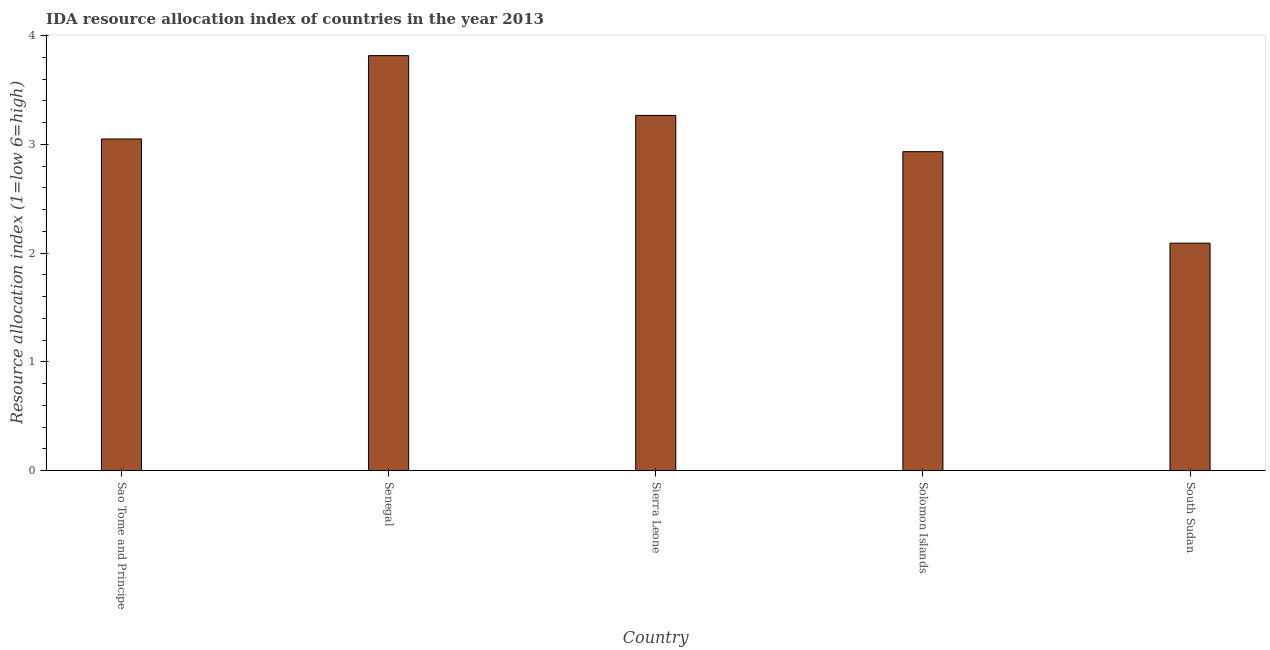Does the graph contain grids?
Keep it short and to the point. No. What is the title of the graph?
Your answer should be very brief. IDA resource allocation index of countries in the year 2013. What is the label or title of the Y-axis?
Keep it short and to the point. Resource allocation index (1=low 6=high). What is the ida resource allocation index in Senegal?
Offer a very short reply. 3.82. Across all countries, what is the maximum ida resource allocation index?
Your response must be concise. 3.82. Across all countries, what is the minimum ida resource allocation index?
Your response must be concise. 2.09. In which country was the ida resource allocation index maximum?
Provide a succinct answer. Senegal. In which country was the ida resource allocation index minimum?
Ensure brevity in your answer.  South Sudan. What is the sum of the ida resource allocation index?
Provide a succinct answer. 15.16. What is the difference between the ida resource allocation index in Sao Tome and Principe and South Sudan?
Make the answer very short. 0.96. What is the average ida resource allocation index per country?
Ensure brevity in your answer.  3.03. What is the median ida resource allocation index?
Your response must be concise. 3.05. What is the ratio of the ida resource allocation index in Sao Tome and Principe to that in Senegal?
Give a very brief answer. 0.8. Is the difference between the ida resource allocation index in Sao Tome and Principe and South Sudan greater than the difference between any two countries?
Provide a short and direct response. No. What is the difference between the highest and the second highest ida resource allocation index?
Your response must be concise. 0.55. Is the sum of the ida resource allocation index in Solomon Islands and South Sudan greater than the maximum ida resource allocation index across all countries?
Your answer should be very brief. Yes. What is the difference between the highest and the lowest ida resource allocation index?
Give a very brief answer. 1.73. In how many countries, is the ida resource allocation index greater than the average ida resource allocation index taken over all countries?
Provide a short and direct response. 3. How many bars are there?
Ensure brevity in your answer.  5. Are all the bars in the graph horizontal?
Your answer should be compact. No. Are the values on the major ticks of Y-axis written in scientific E-notation?
Provide a succinct answer. No. What is the Resource allocation index (1=low 6=high) in Sao Tome and Principe?
Your answer should be very brief. 3.05. What is the Resource allocation index (1=low 6=high) of Senegal?
Provide a succinct answer. 3.82. What is the Resource allocation index (1=low 6=high) in Sierra Leone?
Give a very brief answer. 3.27. What is the Resource allocation index (1=low 6=high) of Solomon Islands?
Make the answer very short. 2.93. What is the Resource allocation index (1=low 6=high) of South Sudan?
Offer a terse response. 2.09. What is the difference between the Resource allocation index (1=low 6=high) in Sao Tome and Principe and Senegal?
Provide a succinct answer. -0.77. What is the difference between the Resource allocation index (1=low 6=high) in Sao Tome and Principe and Sierra Leone?
Offer a very short reply. -0.22. What is the difference between the Resource allocation index (1=low 6=high) in Sao Tome and Principe and Solomon Islands?
Your answer should be very brief. 0.12. What is the difference between the Resource allocation index (1=low 6=high) in Sao Tome and Principe and South Sudan?
Your answer should be compact. 0.96. What is the difference between the Resource allocation index (1=low 6=high) in Senegal and Sierra Leone?
Your response must be concise. 0.55. What is the difference between the Resource allocation index (1=low 6=high) in Senegal and Solomon Islands?
Offer a terse response. 0.88. What is the difference between the Resource allocation index (1=low 6=high) in Senegal and South Sudan?
Your response must be concise. 1.73. What is the difference between the Resource allocation index (1=low 6=high) in Sierra Leone and Solomon Islands?
Your answer should be very brief. 0.33. What is the difference between the Resource allocation index (1=low 6=high) in Sierra Leone and South Sudan?
Ensure brevity in your answer.  1.18. What is the difference between the Resource allocation index (1=low 6=high) in Solomon Islands and South Sudan?
Your response must be concise. 0.84. What is the ratio of the Resource allocation index (1=low 6=high) in Sao Tome and Principe to that in Senegal?
Give a very brief answer. 0.8. What is the ratio of the Resource allocation index (1=low 6=high) in Sao Tome and Principe to that in Sierra Leone?
Give a very brief answer. 0.93. What is the ratio of the Resource allocation index (1=low 6=high) in Sao Tome and Principe to that in South Sudan?
Offer a very short reply. 1.46. What is the ratio of the Resource allocation index (1=low 6=high) in Senegal to that in Sierra Leone?
Give a very brief answer. 1.17. What is the ratio of the Resource allocation index (1=low 6=high) in Senegal to that in Solomon Islands?
Your answer should be compact. 1.3. What is the ratio of the Resource allocation index (1=low 6=high) in Senegal to that in South Sudan?
Offer a terse response. 1.82. What is the ratio of the Resource allocation index (1=low 6=high) in Sierra Leone to that in Solomon Islands?
Give a very brief answer. 1.11. What is the ratio of the Resource allocation index (1=low 6=high) in Sierra Leone to that in South Sudan?
Your answer should be very brief. 1.56. What is the ratio of the Resource allocation index (1=low 6=high) in Solomon Islands to that in South Sudan?
Ensure brevity in your answer.  1.4. 